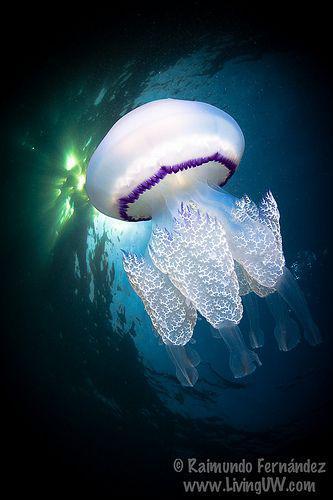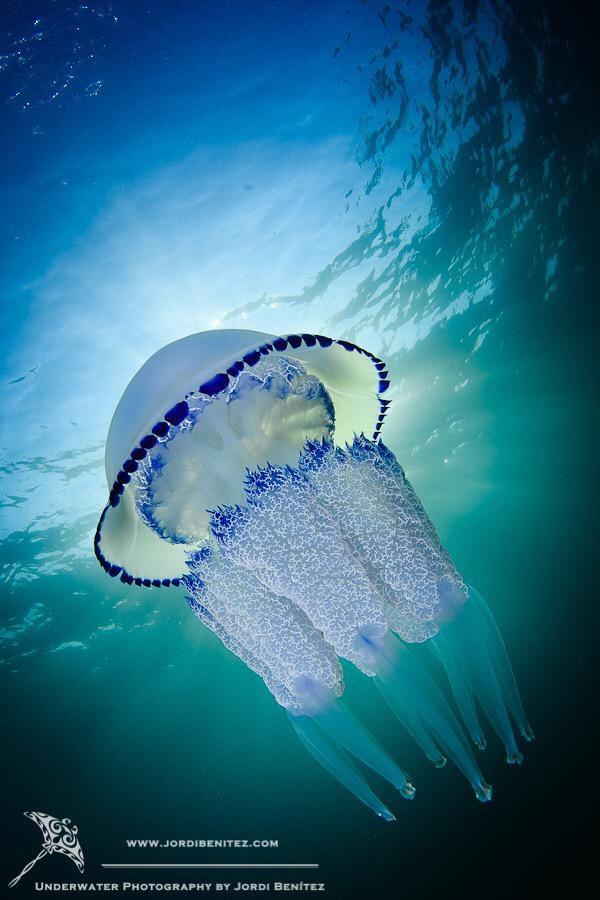The first image is the image on the left, the second image is the image on the right. Analyze the images presented: Is the assertion "The image on the left shows exactly 3 jellyfish." valid? Answer yes or no. No. The first image is the image on the left, the second image is the image on the right. Considering the images on both sides, is "The left image shows at least two translucent blue jellyfish with short tentacles and mushroom shapes, and the right image includes a jellyfish with aqua coloring and longer tentacles." valid? Answer yes or no. No. 